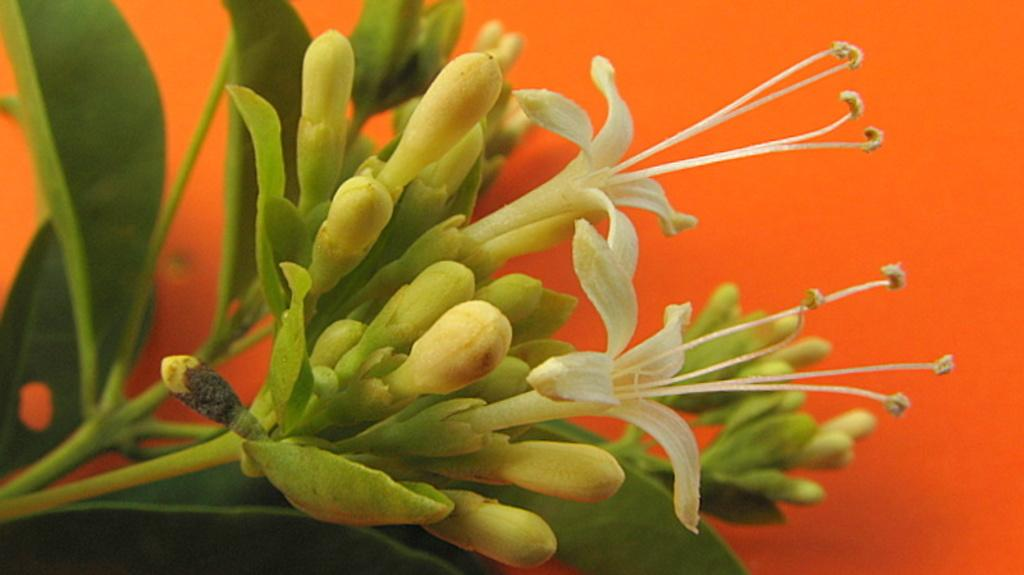What type of plant life is visible in the image? There are flowers and flower buds in the image. What else can be seen in the background of the image? There are leaves in the background of the image. What is the color of the background in the image? The background has an orange color. What type of question is being asked in the image? There is no question present in the image; it features flowers, flower buds, leaves, and an orange background. 